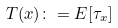Convert formula to latex. <formula><loc_0><loc_0><loc_500><loc_500>T ( x ) \colon = E [ \tau _ { x } ]</formula> 